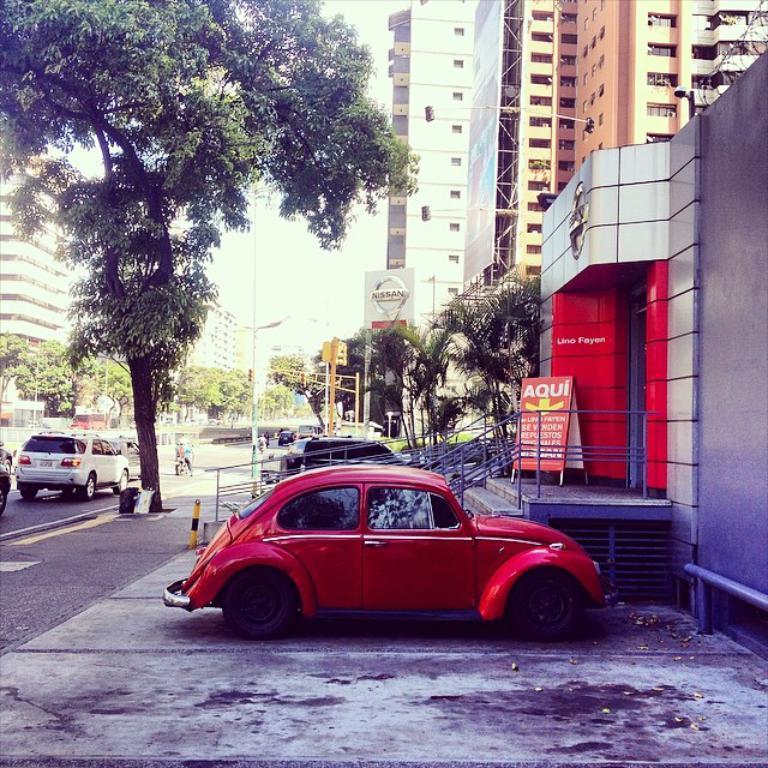Can you describe this image briefly? In this picture we can see the red color car parked in the front. Behind there is a railing and shop. In the background there are some buildings. On the left side there is a tree and some cars moving on the road. 